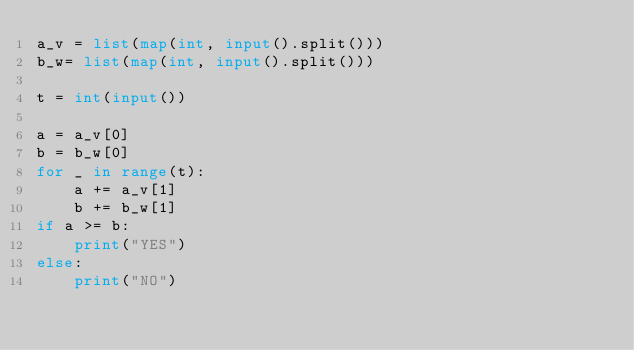Convert code to text. <code><loc_0><loc_0><loc_500><loc_500><_Python_>a_v = list(map(int, input().split()))
b_w= list(map(int, input().split()))

t = int(input())

a = a_v[0]
b = b_w[0]
for _ in range(t):
    a += a_v[1]
    b += b_w[1]
if a >= b:
    print("YES")
else:
    print("NO")</code> 